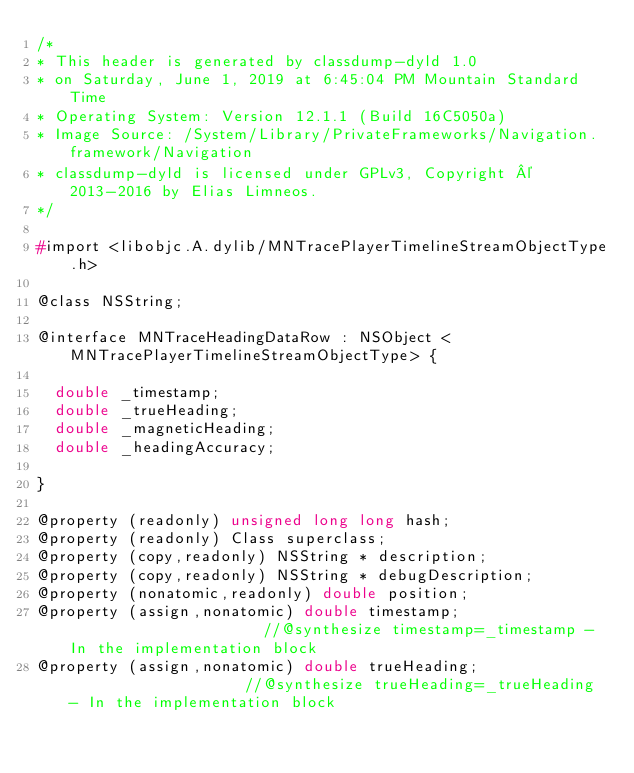<code> <loc_0><loc_0><loc_500><loc_500><_C_>/*
* This header is generated by classdump-dyld 1.0
* on Saturday, June 1, 2019 at 6:45:04 PM Mountain Standard Time
* Operating System: Version 12.1.1 (Build 16C5050a)
* Image Source: /System/Library/PrivateFrameworks/Navigation.framework/Navigation
* classdump-dyld is licensed under GPLv3, Copyright © 2013-2016 by Elias Limneos.
*/

#import <libobjc.A.dylib/MNTracePlayerTimelineStreamObjectType.h>

@class NSString;

@interface MNTraceHeadingDataRow : NSObject <MNTracePlayerTimelineStreamObjectType> {

	double _timestamp;
	double _trueHeading;
	double _magneticHeading;
	double _headingAccuracy;

}

@property (readonly) unsigned long long hash; 
@property (readonly) Class superclass; 
@property (copy,readonly) NSString * description; 
@property (copy,readonly) NSString * debugDescription; 
@property (nonatomic,readonly) double position; 
@property (assign,nonatomic) double timestamp;                      //@synthesize timestamp=_timestamp - In the implementation block
@property (assign,nonatomic) double trueHeading;                    //@synthesize trueHeading=_trueHeading - In the implementation block</code> 